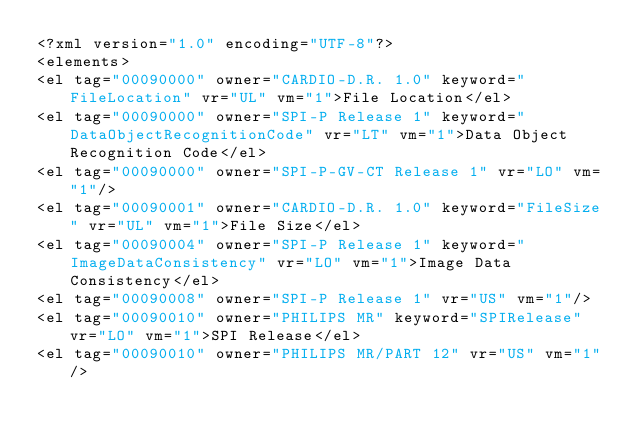<code> <loc_0><loc_0><loc_500><loc_500><_XML_><?xml version="1.0" encoding="UTF-8"?>
<elements>
<el tag="00090000" owner="CARDIO-D.R. 1.0" keyword="FileLocation" vr="UL" vm="1">File Location</el>
<el tag="00090000" owner="SPI-P Release 1" keyword="DataObjectRecognitionCode" vr="LT" vm="1">Data Object Recognition Code</el>
<el tag="00090000" owner="SPI-P-GV-CT Release 1" vr="LO" vm="1"/>
<el tag="00090001" owner="CARDIO-D.R. 1.0" keyword="FileSize" vr="UL" vm="1">File Size</el>
<el tag="00090004" owner="SPI-P Release 1" keyword="ImageDataConsistency" vr="LO" vm="1">Image Data Consistency</el>
<el tag="00090008" owner="SPI-P Release 1" vr="US" vm="1"/>
<el tag="00090010" owner="PHILIPS MR" keyword="SPIRelease" vr="LO" vm="1">SPI Release</el>
<el tag="00090010" owner="PHILIPS MR/PART 12" vr="US" vm="1"/></code> 